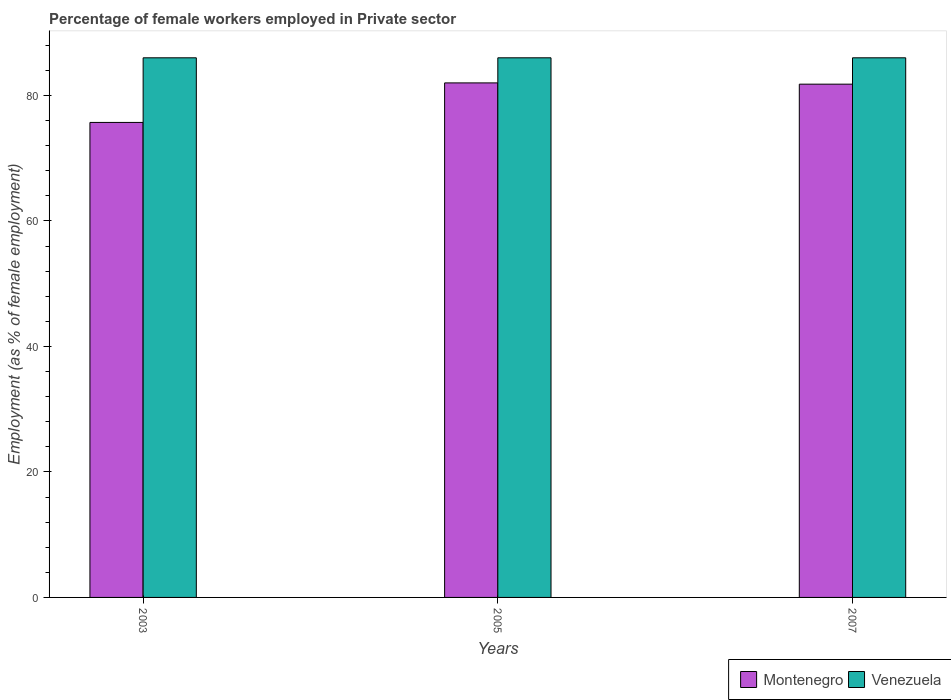Are the number of bars per tick equal to the number of legend labels?
Your response must be concise. Yes. Are the number of bars on each tick of the X-axis equal?
Your answer should be very brief. Yes. What is the label of the 2nd group of bars from the left?
Provide a succinct answer. 2005. In how many cases, is the number of bars for a given year not equal to the number of legend labels?
Make the answer very short. 0. What is the percentage of females employed in Private sector in Montenegro in 2003?
Provide a succinct answer. 75.7. In which year was the percentage of females employed in Private sector in Venezuela maximum?
Keep it short and to the point. 2003. What is the total percentage of females employed in Private sector in Montenegro in the graph?
Ensure brevity in your answer.  239.5. What is the difference between the percentage of females employed in Private sector in Venezuela in 2005 and the percentage of females employed in Private sector in Montenegro in 2003?
Keep it short and to the point. 10.3. In the year 2007, what is the difference between the percentage of females employed in Private sector in Venezuela and percentage of females employed in Private sector in Montenegro?
Ensure brevity in your answer.  4.2. In how many years, is the percentage of females employed in Private sector in Venezuela greater than 4 %?
Offer a very short reply. 3. What is the ratio of the percentage of females employed in Private sector in Venezuela in 2005 to that in 2007?
Make the answer very short. 1. What is the difference between the highest and the second highest percentage of females employed in Private sector in Montenegro?
Provide a short and direct response. 0.2. What is the difference between the highest and the lowest percentage of females employed in Private sector in Venezuela?
Offer a very short reply. 0. Is the sum of the percentage of females employed in Private sector in Venezuela in 2003 and 2005 greater than the maximum percentage of females employed in Private sector in Montenegro across all years?
Offer a terse response. Yes. What does the 2nd bar from the left in 2007 represents?
Your answer should be compact. Venezuela. What does the 2nd bar from the right in 2005 represents?
Make the answer very short. Montenegro. Are all the bars in the graph horizontal?
Provide a short and direct response. No. How many years are there in the graph?
Provide a succinct answer. 3. What is the difference between two consecutive major ticks on the Y-axis?
Provide a succinct answer. 20. Does the graph contain any zero values?
Provide a succinct answer. No. Where does the legend appear in the graph?
Offer a terse response. Bottom right. How are the legend labels stacked?
Make the answer very short. Horizontal. What is the title of the graph?
Ensure brevity in your answer.  Percentage of female workers employed in Private sector. What is the label or title of the X-axis?
Ensure brevity in your answer.  Years. What is the label or title of the Y-axis?
Provide a short and direct response. Employment (as % of female employment). What is the Employment (as % of female employment) in Montenegro in 2003?
Your answer should be very brief. 75.7. What is the Employment (as % of female employment) of Venezuela in 2003?
Provide a short and direct response. 86. What is the Employment (as % of female employment) of Montenegro in 2007?
Your response must be concise. 81.8. Across all years, what is the minimum Employment (as % of female employment) of Montenegro?
Ensure brevity in your answer.  75.7. What is the total Employment (as % of female employment) of Montenegro in the graph?
Your answer should be compact. 239.5. What is the total Employment (as % of female employment) of Venezuela in the graph?
Make the answer very short. 258. What is the difference between the Employment (as % of female employment) in Venezuela in 2003 and that in 2007?
Provide a short and direct response. 0. What is the difference between the Employment (as % of female employment) in Montenegro in 2005 and that in 2007?
Your answer should be very brief. 0.2. What is the difference between the Employment (as % of female employment) of Venezuela in 2005 and that in 2007?
Ensure brevity in your answer.  0. What is the difference between the Employment (as % of female employment) of Montenegro in 2003 and the Employment (as % of female employment) of Venezuela in 2005?
Your response must be concise. -10.3. What is the difference between the Employment (as % of female employment) in Montenegro in 2005 and the Employment (as % of female employment) in Venezuela in 2007?
Provide a succinct answer. -4. What is the average Employment (as % of female employment) in Montenegro per year?
Your answer should be compact. 79.83. What is the average Employment (as % of female employment) in Venezuela per year?
Make the answer very short. 86. What is the ratio of the Employment (as % of female employment) in Montenegro in 2003 to that in 2005?
Your answer should be compact. 0.92. What is the ratio of the Employment (as % of female employment) of Venezuela in 2003 to that in 2005?
Provide a short and direct response. 1. What is the ratio of the Employment (as % of female employment) of Montenegro in 2003 to that in 2007?
Provide a succinct answer. 0.93. What is the ratio of the Employment (as % of female employment) in Montenegro in 2005 to that in 2007?
Offer a very short reply. 1. What is the difference between the highest and the second highest Employment (as % of female employment) of Montenegro?
Offer a very short reply. 0.2. What is the difference between the highest and the lowest Employment (as % of female employment) of Venezuela?
Your response must be concise. 0. 